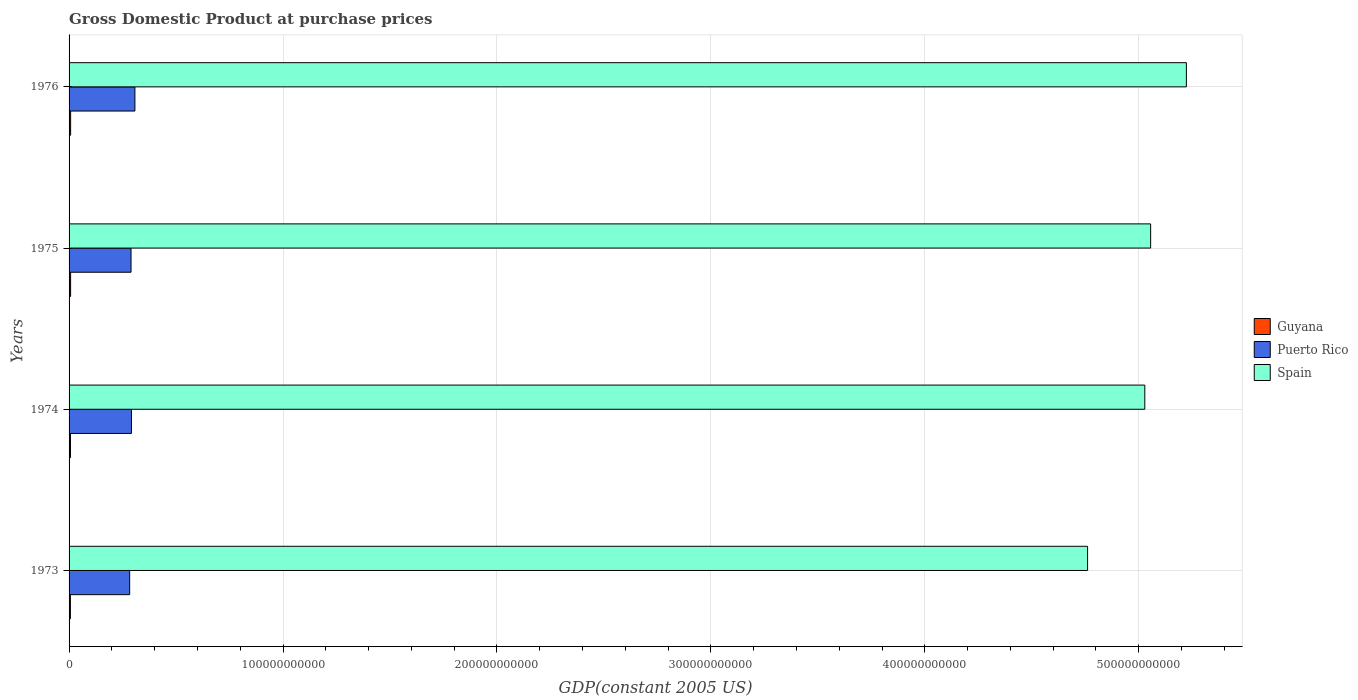How many different coloured bars are there?
Offer a very short reply. 3. Are the number of bars per tick equal to the number of legend labels?
Offer a terse response. Yes. Are the number of bars on each tick of the Y-axis equal?
Ensure brevity in your answer.  Yes. How many bars are there on the 4th tick from the bottom?
Offer a very short reply. 3. What is the label of the 3rd group of bars from the top?
Provide a succinct answer. 1974. In how many cases, is the number of bars for a given year not equal to the number of legend labels?
Provide a short and direct response. 0. What is the GDP at purchase prices in Puerto Rico in 1974?
Your answer should be very brief. 2.92e+1. Across all years, what is the maximum GDP at purchase prices in Puerto Rico?
Provide a short and direct response. 3.08e+1. Across all years, what is the minimum GDP at purchase prices in Guyana?
Your response must be concise. 6.15e+08. In which year was the GDP at purchase prices in Guyana maximum?
Make the answer very short. 1976. What is the total GDP at purchase prices in Puerto Rico in the graph?
Your response must be concise. 1.17e+11. What is the difference between the GDP at purchase prices in Guyana in 1973 and that in 1975?
Offer a very short reply. -1.04e+08. What is the difference between the GDP at purchase prices in Spain in 1973 and the GDP at purchase prices in Puerto Rico in 1976?
Provide a short and direct response. 4.45e+11. What is the average GDP at purchase prices in Spain per year?
Give a very brief answer. 5.02e+11. In the year 1976, what is the difference between the GDP at purchase prices in Guyana and GDP at purchase prices in Spain?
Your response must be concise. -5.22e+11. What is the ratio of the GDP at purchase prices in Puerto Rico in 1974 to that in 1976?
Give a very brief answer. 0.95. What is the difference between the highest and the second highest GDP at purchase prices in Puerto Rico?
Your answer should be very brief. 1.62e+09. What is the difference between the highest and the lowest GDP at purchase prices in Spain?
Offer a very short reply. 4.62e+1. In how many years, is the GDP at purchase prices in Guyana greater than the average GDP at purchase prices in Guyana taken over all years?
Provide a short and direct response. 2. What does the 1st bar from the top in 1973 represents?
Provide a succinct answer. Spain. What does the 2nd bar from the bottom in 1976 represents?
Give a very brief answer. Puerto Rico. Is it the case that in every year, the sum of the GDP at purchase prices in Spain and GDP at purchase prices in Guyana is greater than the GDP at purchase prices in Puerto Rico?
Provide a short and direct response. Yes. How many bars are there?
Make the answer very short. 12. How many years are there in the graph?
Provide a short and direct response. 4. What is the difference between two consecutive major ticks on the X-axis?
Provide a short and direct response. 1.00e+11. Does the graph contain any zero values?
Offer a very short reply. No. Does the graph contain grids?
Provide a short and direct response. Yes. Where does the legend appear in the graph?
Keep it short and to the point. Center right. How many legend labels are there?
Give a very brief answer. 3. What is the title of the graph?
Keep it short and to the point. Gross Domestic Product at purchase prices. Does "Italy" appear as one of the legend labels in the graph?
Your answer should be compact. No. What is the label or title of the X-axis?
Make the answer very short. GDP(constant 2005 US). What is the label or title of the Y-axis?
Your answer should be compact. Years. What is the GDP(constant 2005 US) of Guyana in 1973?
Keep it short and to the point. 6.15e+08. What is the GDP(constant 2005 US) in Puerto Rico in 1973?
Your answer should be compact. 2.83e+1. What is the GDP(constant 2005 US) in Spain in 1973?
Keep it short and to the point. 4.76e+11. What is the GDP(constant 2005 US) of Guyana in 1974?
Your response must be concise. 6.63e+08. What is the GDP(constant 2005 US) in Puerto Rico in 1974?
Provide a succinct answer. 2.92e+1. What is the GDP(constant 2005 US) of Spain in 1974?
Provide a succinct answer. 5.03e+11. What is the GDP(constant 2005 US) of Guyana in 1975?
Your answer should be very brief. 7.19e+08. What is the GDP(constant 2005 US) of Puerto Rico in 1975?
Provide a succinct answer. 2.90e+1. What is the GDP(constant 2005 US) of Spain in 1975?
Offer a very short reply. 5.06e+11. What is the GDP(constant 2005 US) in Guyana in 1976?
Provide a succinct answer. 7.30e+08. What is the GDP(constant 2005 US) in Puerto Rico in 1976?
Provide a short and direct response. 3.08e+1. What is the GDP(constant 2005 US) of Spain in 1976?
Offer a terse response. 5.22e+11. Across all years, what is the maximum GDP(constant 2005 US) of Guyana?
Your response must be concise. 7.30e+08. Across all years, what is the maximum GDP(constant 2005 US) in Puerto Rico?
Make the answer very short. 3.08e+1. Across all years, what is the maximum GDP(constant 2005 US) of Spain?
Make the answer very short. 5.22e+11. Across all years, what is the minimum GDP(constant 2005 US) in Guyana?
Your answer should be compact. 6.15e+08. Across all years, what is the minimum GDP(constant 2005 US) of Puerto Rico?
Provide a succinct answer. 2.83e+1. Across all years, what is the minimum GDP(constant 2005 US) in Spain?
Offer a very short reply. 4.76e+11. What is the total GDP(constant 2005 US) in Guyana in the graph?
Your response must be concise. 2.73e+09. What is the total GDP(constant 2005 US) of Puerto Rico in the graph?
Keep it short and to the point. 1.17e+11. What is the total GDP(constant 2005 US) in Spain in the graph?
Keep it short and to the point. 2.01e+12. What is the difference between the GDP(constant 2005 US) of Guyana in 1973 and that in 1974?
Offer a very short reply. -4.74e+07. What is the difference between the GDP(constant 2005 US) in Puerto Rico in 1973 and that in 1974?
Keep it short and to the point. -8.26e+08. What is the difference between the GDP(constant 2005 US) in Spain in 1973 and that in 1974?
Your answer should be compact. -2.67e+1. What is the difference between the GDP(constant 2005 US) of Guyana in 1973 and that in 1975?
Make the answer very short. -1.04e+08. What is the difference between the GDP(constant 2005 US) in Puerto Rico in 1973 and that in 1975?
Provide a succinct answer. -6.36e+08. What is the difference between the GDP(constant 2005 US) in Spain in 1973 and that in 1975?
Your response must be concise. -2.95e+1. What is the difference between the GDP(constant 2005 US) of Guyana in 1973 and that in 1976?
Give a very brief answer. -1.15e+08. What is the difference between the GDP(constant 2005 US) in Puerto Rico in 1973 and that in 1976?
Your answer should be compact. -2.44e+09. What is the difference between the GDP(constant 2005 US) of Spain in 1973 and that in 1976?
Provide a short and direct response. -4.62e+1. What is the difference between the GDP(constant 2005 US) in Guyana in 1974 and that in 1975?
Keep it short and to the point. -5.62e+07. What is the difference between the GDP(constant 2005 US) in Puerto Rico in 1974 and that in 1975?
Provide a succinct answer. 1.91e+08. What is the difference between the GDP(constant 2005 US) in Spain in 1974 and that in 1975?
Ensure brevity in your answer.  -2.73e+09. What is the difference between the GDP(constant 2005 US) in Guyana in 1974 and that in 1976?
Provide a short and direct response. -6.73e+07. What is the difference between the GDP(constant 2005 US) of Puerto Rico in 1974 and that in 1976?
Make the answer very short. -1.62e+09. What is the difference between the GDP(constant 2005 US) in Spain in 1974 and that in 1976?
Ensure brevity in your answer.  -1.94e+1. What is the difference between the GDP(constant 2005 US) in Guyana in 1975 and that in 1976?
Your answer should be compact. -1.10e+07. What is the difference between the GDP(constant 2005 US) in Puerto Rico in 1975 and that in 1976?
Offer a very short reply. -1.81e+09. What is the difference between the GDP(constant 2005 US) of Spain in 1975 and that in 1976?
Offer a terse response. -1.67e+1. What is the difference between the GDP(constant 2005 US) of Guyana in 1973 and the GDP(constant 2005 US) of Puerto Rico in 1974?
Your answer should be very brief. -2.85e+1. What is the difference between the GDP(constant 2005 US) in Guyana in 1973 and the GDP(constant 2005 US) in Spain in 1974?
Your response must be concise. -5.02e+11. What is the difference between the GDP(constant 2005 US) in Puerto Rico in 1973 and the GDP(constant 2005 US) in Spain in 1974?
Your answer should be compact. -4.74e+11. What is the difference between the GDP(constant 2005 US) in Guyana in 1973 and the GDP(constant 2005 US) in Puerto Rico in 1975?
Provide a succinct answer. -2.83e+1. What is the difference between the GDP(constant 2005 US) of Guyana in 1973 and the GDP(constant 2005 US) of Spain in 1975?
Offer a very short reply. -5.05e+11. What is the difference between the GDP(constant 2005 US) of Puerto Rico in 1973 and the GDP(constant 2005 US) of Spain in 1975?
Your answer should be very brief. -4.77e+11. What is the difference between the GDP(constant 2005 US) in Guyana in 1973 and the GDP(constant 2005 US) in Puerto Rico in 1976?
Your answer should be compact. -3.02e+1. What is the difference between the GDP(constant 2005 US) in Guyana in 1973 and the GDP(constant 2005 US) in Spain in 1976?
Your answer should be compact. -5.22e+11. What is the difference between the GDP(constant 2005 US) of Puerto Rico in 1973 and the GDP(constant 2005 US) of Spain in 1976?
Your response must be concise. -4.94e+11. What is the difference between the GDP(constant 2005 US) in Guyana in 1974 and the GDP(constant 2005 US) in Puerto Rico in 1975?
Keep it short and to the point. -2.83e+1. What is the difference between the GDP(constant 2005 US) of Guyana in 1974 and the GDP(constant 2005 US) of Spain in 1975?
Make the answer very short. -5.05e+11. What is the difference between the GDP(constant 2005 US) in Puerto Rico in 1974 and the GDP(constant 2005 US) in Spain in 1975?
Provide a short and direct response. -4.76e+11. What is the difference between the GDP(constant 2005 US) in Guyana in 1974 and the GDP(constant 2005 US) in Puerto Rico in 1976?
Provide a succinct answer. -3.01e+1. What is the difference between the GDP(constant 2005 US) of Guyana in 1974 and the GDP(constant 2005 US) of Spain in 1976?
Offer a terse response. -5.22e+11. What is the difference between the GDP(constant 2005 US) in Puerto Rico in 1974 and the GDP(constant 2005 US) in Spain in 1976?
Your answer should be compact. -4.93e+11. What is the difference between the GDP(constant 2005 US) in Guyana in 1975 and the GDP(constant 2005 US) in Puerto Rico in 1976?
Your answer should be very brief. -3.01e+1. What is the difference between the GDP(constant 2005 US) in Guyana in 1975 and the GDP(constant 2005 US) in Spain in 1976?
Your answer should be compact. -5.22e+11. What is the difference between the GDP(constant 2005 US) of Puerto Rico in 1975 and the GDP(constant 2005 US) of Spain in 1976?
Make the answer very short. -4.93e+11. What is the average GDP(constant 2005 US) of Guyana per year?
Give a very brief answer. 6.82e+08. What is the average GDP(constant 2005 US) of Puerto Rico per year?
Keep it short and to the point. 2.93e+1. What is the average GDP(constant 2005 US) of Spain per year?
Offer a very short reply. 5.02e+11. In the year 1973, what is the difference between the GDP(constant 2005 US) in Guyana and GDP(constant 2005 US) in Puerto Rico?
Ensure brevity in your answer.  -2.77e+1. In the year 1973, what is the difference between the GDP(constant 2005 US) in Guyana and GDP(constant 2005 US) in Spain?
Give a very brief answer. -4.75e+11. In the year 1973, what is the difference between the GDP(constant 2005 US) of Puerto Rico and GDP(constant 2005 US) of Spain?
Your response must be concise. -4.48e+11. In the year 1974, what is the difference between the GDP(constant 2005 US) in Guyana and GDP(constant 2005 US) in Puerto Rico?
Your response must be concise. -2.85e+1. In the year 1974, what is the difference between the GDP(constant 2005 US) of Guyana and GDP(constant 2005 US) of Spain?
Give a very brief answer. -5.02e+11. In the year 1974, what is the difference between the GDP(constant 2005 US) of Puerto Rico and GDP(constant 2005 US) of Spain?
Offer a very short reply. -4.74e+11. In the year 1975, what is the difference between the GDP(constant 2005 US) in Guyana and GDP(constant 2005 US) in Puerto Rico?
Offer a terse response. -2.82e+1. In the year 1975, what is the difference between the GDP(constant 2005 US) in Guyana and GDP(constant 2005 US) in Spain?
Give a very brief answer. -5.05e+11. In the year 1975, what is the difference between the GDP(constant 2005 US) of Puerto Rico and GDP(constant 2005 US) of Spain?
Provide a succinct answer. -4.77e+11. In the year 1976, what is the difference between the GDP(constant 2005 US) of Guyana and GDP(constant 2005 US) of Puerto Rico?
Your answer should be very brief. -3.00e+1. In the year 1976, what is the difference between the GDP(constant 2005 US) in Guyana and GDP(constant 2005 US) in Spain?
Your response must be concise. -5.22e+11. In the year 1976, what is the difference between the GDP(constant 2005 US) of Puerto Rico and GDP(constant 2005 US) of Spain?
Offer a terse response. -4.91e+11. What is the ratio of the GDP(constant 2005 US) in Guyana in 1973 to that in 1974?
Keep it short and to the point. 0.93. What is the ratio of the GDP(constant 2005 US) in Puerto Rico in 1973 to that in 1974?
Give a very brief answer. 0.97. What is the ratio of the GDP(constant 2005 US) in Spain in 1973 to that in 1974?
Your answer should be very brief. 0.95. What is the ratio of the GDP(constant 2005 US) of Guyana in 1973 to that in 1975?
Offer a terse response. 0.86. What is the ratio of the GDP(constant 2005 US) of Puerto Rico in 1973 to that in 1975?
Your response must be concise. 0.98. What is the ratio of the GDP(constant 2005 US) in Spain in 1973 to that in 1975?
Your answer should be very brief. 0.94. What is the ratio of the GDP(constant 2005 US) in Guyana in 1973 to that in 1976?
Your answer should be very brief. 0.84. What is the ratio of the GDP(constant 2005 US) in Puerto Rico in 1973 to that in 1976?
Make the answer very short. 0.92. What is the ratio of the GDP(constant 2005 US) in Spain in 1973 to that in 1976?
Keep it short and to the point. 0.91. What is the ratio of the GDP(constant 2005 US) in Guyana in 1974 to that in 1975?
Provide a short and direct response. 0.92. What is the ratio of the GDP(constant 2005 US) in Puerto Rico in 1974 to that in 1975?
Provide a succinct answer. 1.01. What is the ratio of the GDP(constant 2005 US) of Guyana in 1974 to that in 1976?
Offer a terse response. 0.91. What is the ratio of the GDP(constant 2005 US) of Puerto Rico in 1974 to that in 1976?
Your answer should be very brief. 0.95. What is the ratio of the GDP(constant 2005 US) of Spain in 1974 to that in 1976?
Keep it short and to the point. 0.96. What is the ratio of the GDP(constant 2005 US) of Guyana in 1975 to that in 1976?
Keep it short and to the point. 0.98. What is the ratio of the GDP(constant 2005 US) of Puerto Rico in 1975 to that in 1976?
Provide a succinct answer. 0.94. What is the ratio of the GDP(constant 2005 US) of Spain in 1975 to that in 1976?
Give a very brief answer. 0.97. What is the difference between the highest and the second highest GDP(constant 2005 US) in Guyana?
Your response must be concise. 1.10e+07. What is the difference between the highest and the second highest GDP(constant 2005 US) of Puerto Rico?
Keep it short and to the point. 1.62e+09. What is the difference between the highest and the second highest GDP(constant 2005 US) in Spain?
Your response must be concise. 1.67e+1. What is the difference between the highest and the lowest GDP(constant 2005 US) of Guyana?
Ensure brevity in your answer.  1.15e+08. What is the difference between the highest and the lowest GDP(constant 2005 US) in Puerto Rico?
Provide a succinct answer. 2.44e+09. What is the difference between the highest and the lowest GDP(constant 2005 US) of Spain?
Your answer should be compact. 4.62e+1. 